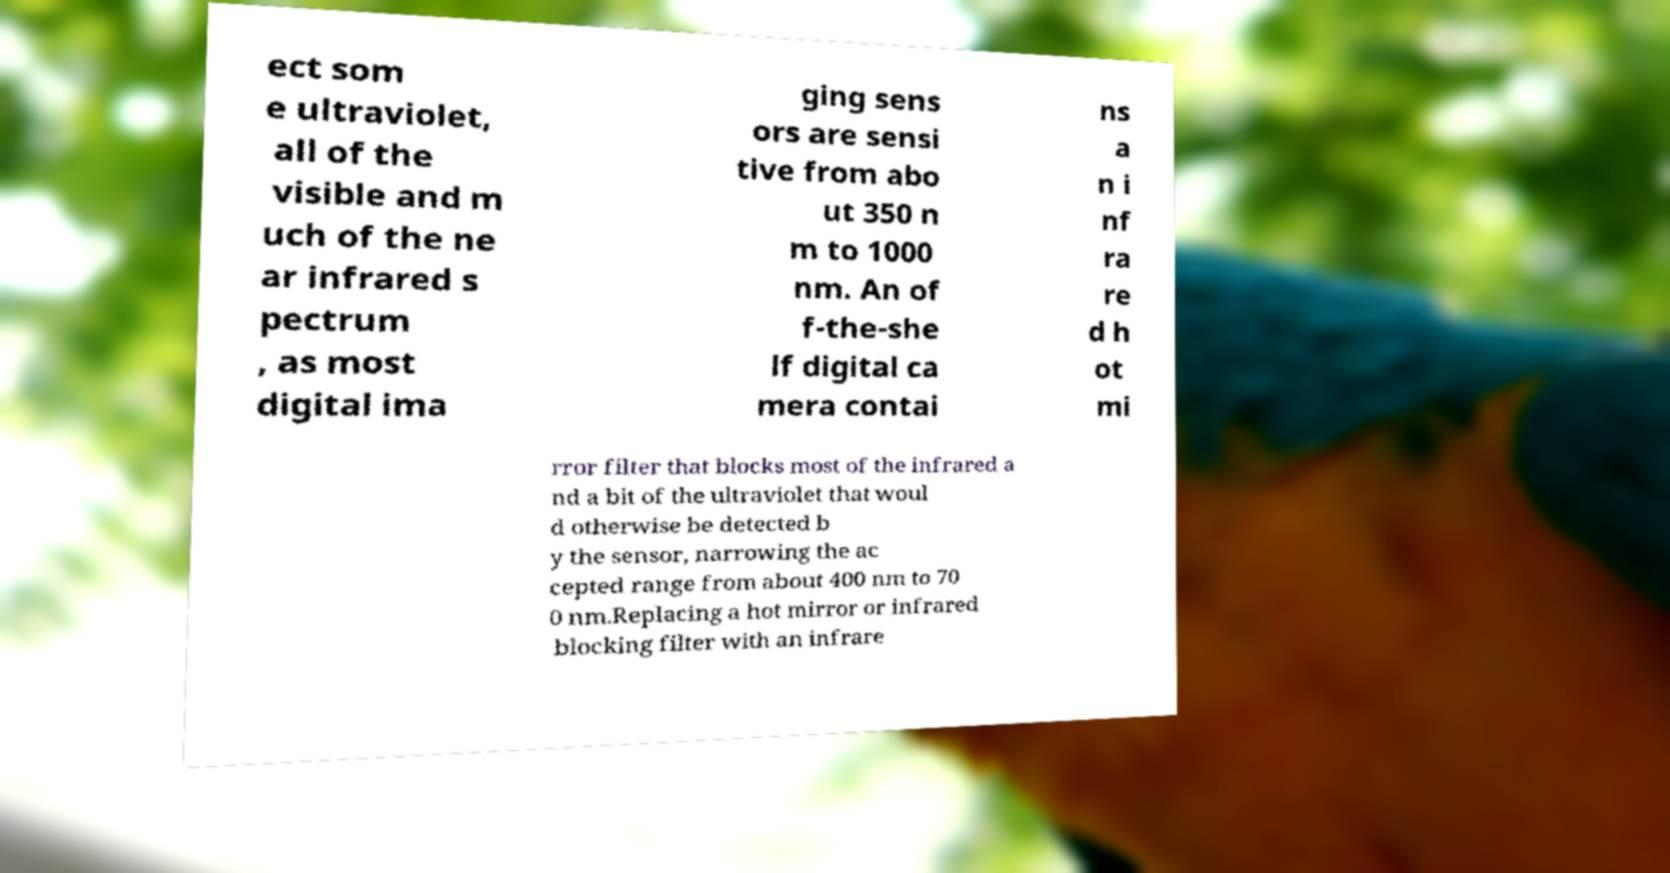I need the written content from this picture converted into text. Can you do that? ect som e ultraviolet, all of the visible and m uch of the ne ar infrared s pectrum , as most digital ima ging sens ors are sensi tive from abo ut 350 n m to 1000 nm. An of f-the-she lf digital ca mera contai ns a n i nf ra re d h ot mi rror filter that blocks most of the infrared a nd a bit of the ultraviolet that woul d otherwise be detected b y the sensor, narrowing the ac cepted range from about 400 nm to 70 0 nm.Replacing a hot mirror or infrared blocking filter with an infrare 